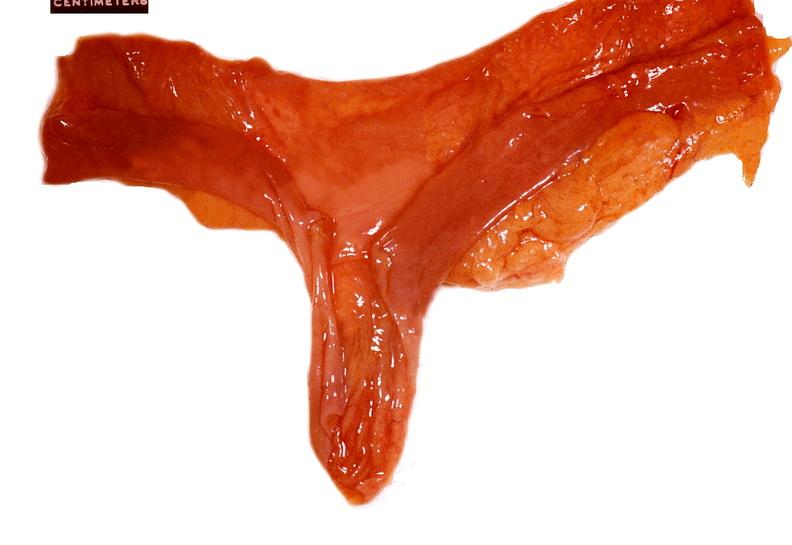what is present?
Answer the question using a single word or phrase. Gastrointestinal 